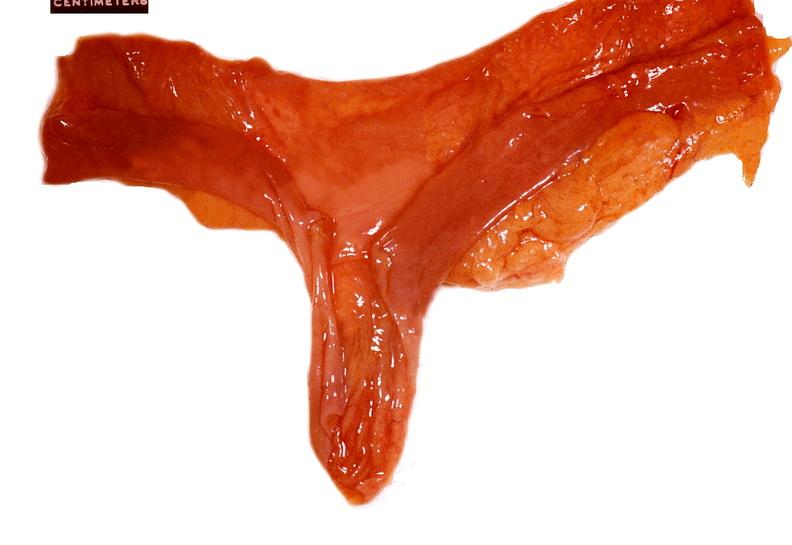what is present?
Answer the question using a single word or phrase. Gastrointestinal 